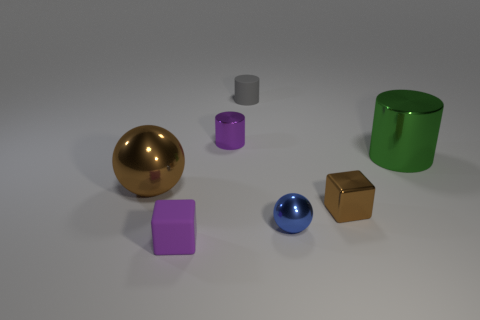How would you describe the lighting and shadows in the scene? The lighting in the scene is soft and diffused, casting gentle shadows beneath each object. The direction of the light appears to be coming from above, slightly favoring the left side, which contributes to the depth and dimensionality of the objects. 